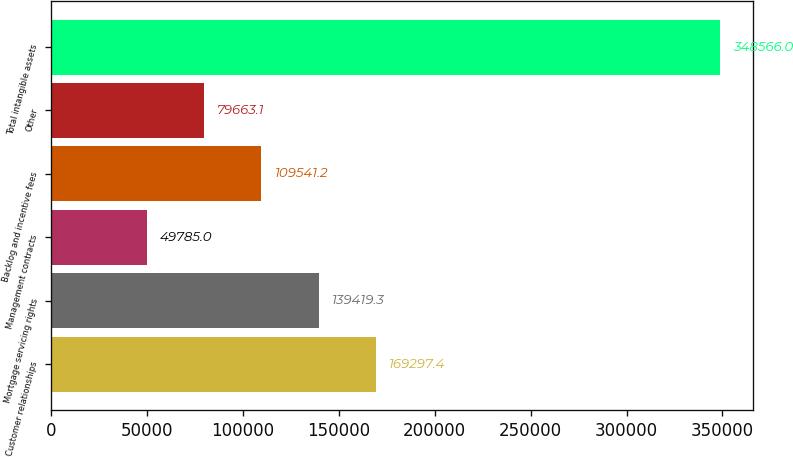<chart> <loc_0><loc_0><loc_500><loc_500><bar_chart><fcel>Customer relationships<fcel>Mortgage servicing rights<fcel>Management contracts<fcel>Backlog and incentive fees<fcel>Other<fcel>Total intangible assets<nl><fcel>169297<fcel>139419<fcel>49785<fcel>109541<fcel>79663.1<fcel>348566<nl></chart> 